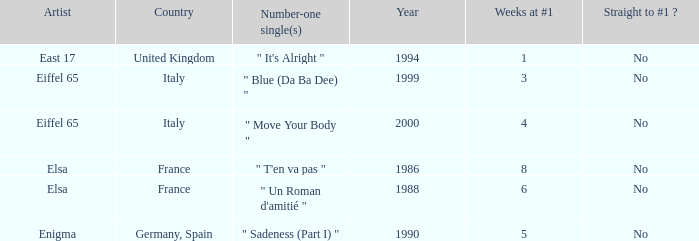How many years have a weeks at #1 value of exactly 8? 1.0. 